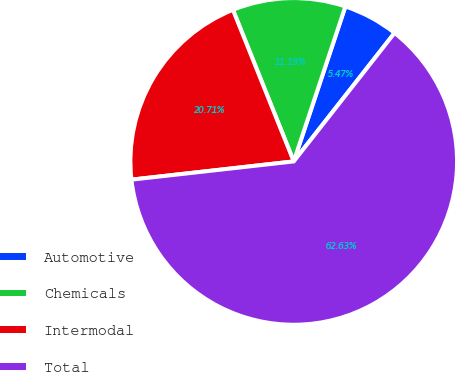Convert chart. <chart><loc_0><loc_0><loc_500><loc_500><pie_chart><fcel>Automotive<fcel>Chemicals<fcel>Intermodal<fcel>Total<nl><fcel>5.47%<fcel>11.19%<fcel>20.71%<fcel>62.63%<nl></chart> 